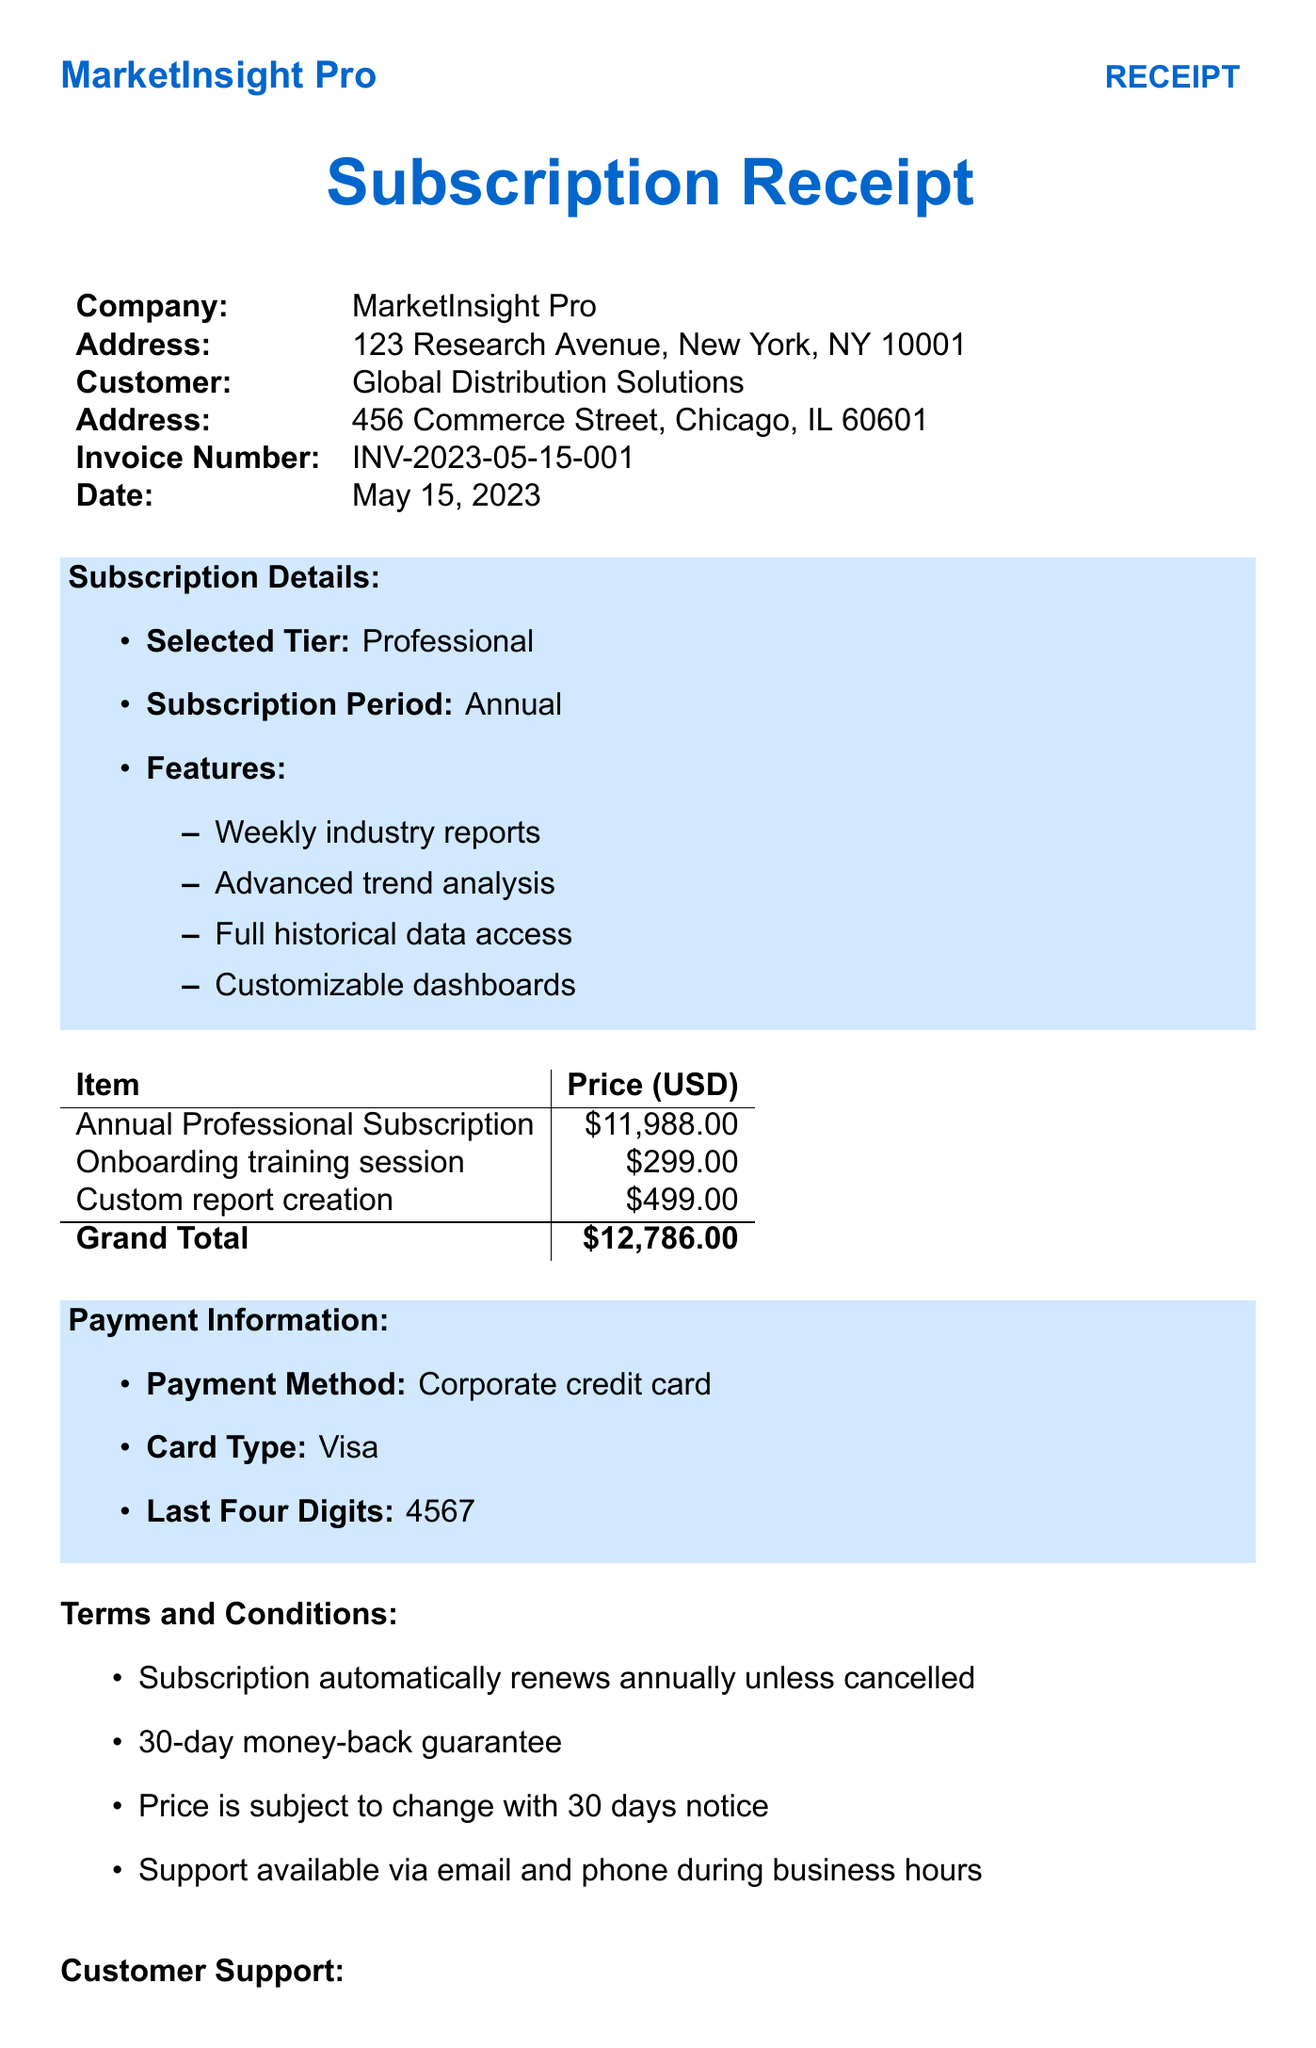what is the company name? The company name is the first item listed in the document, which identifies the provider of the service.
Answer: MarketInsight Pro what is the invoice number? The invoice number is a unique identifier for this transaction, located in the document's detail section.
Answer: INV-2023-05-15-001 how much is the total price for the subscription? The total price for the subscription is specified in the itemized pricing section of the receipt.
Answer: 11988 which subscription tier was selected? The selected subscription tier is clearly stated in the subscription details section of the document.
Answer: Professional what is the price of the onboarding training session? The price for this additional service is mentioned in the itemized pricing section of the receipt.
Answer: 299 how many features are included in the Professional subscription tier? The number of features included is determined by counting the items listed under the subscription details for the selected tier.
Answer: 4 what is the payment method used? The payment method is specified in the payment information section of the document.
Answer: Corporate credit card is there a money-back guarantee? The terms and conditions mention whether a money-back guarantee is provided or not.
Answer: Yes what services incur additional costs on top of the subscription? These services are listed in the additional services section of the document.
Answer: Onboarding training session, Custom report creation 